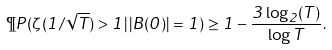Convert formula to latex. <formula><loc_0><loc_0><loc_500><loc_500>\P P ( \zeta ( 1 / \sqrt { T } ) > 1 | \, | B ( 0 ) | = 1 ) \geq 1 - \frac { 3 \log _ { 2 } ( T ) } { \log T } .</formula> 